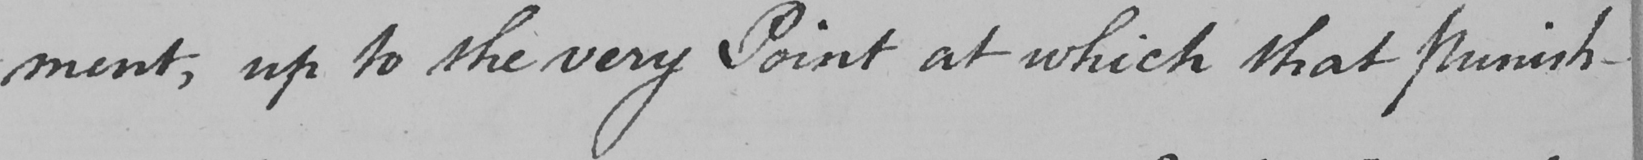Transcribe the text shown in this historical manuscript line. -ment , up to the very Point at which that punish- 